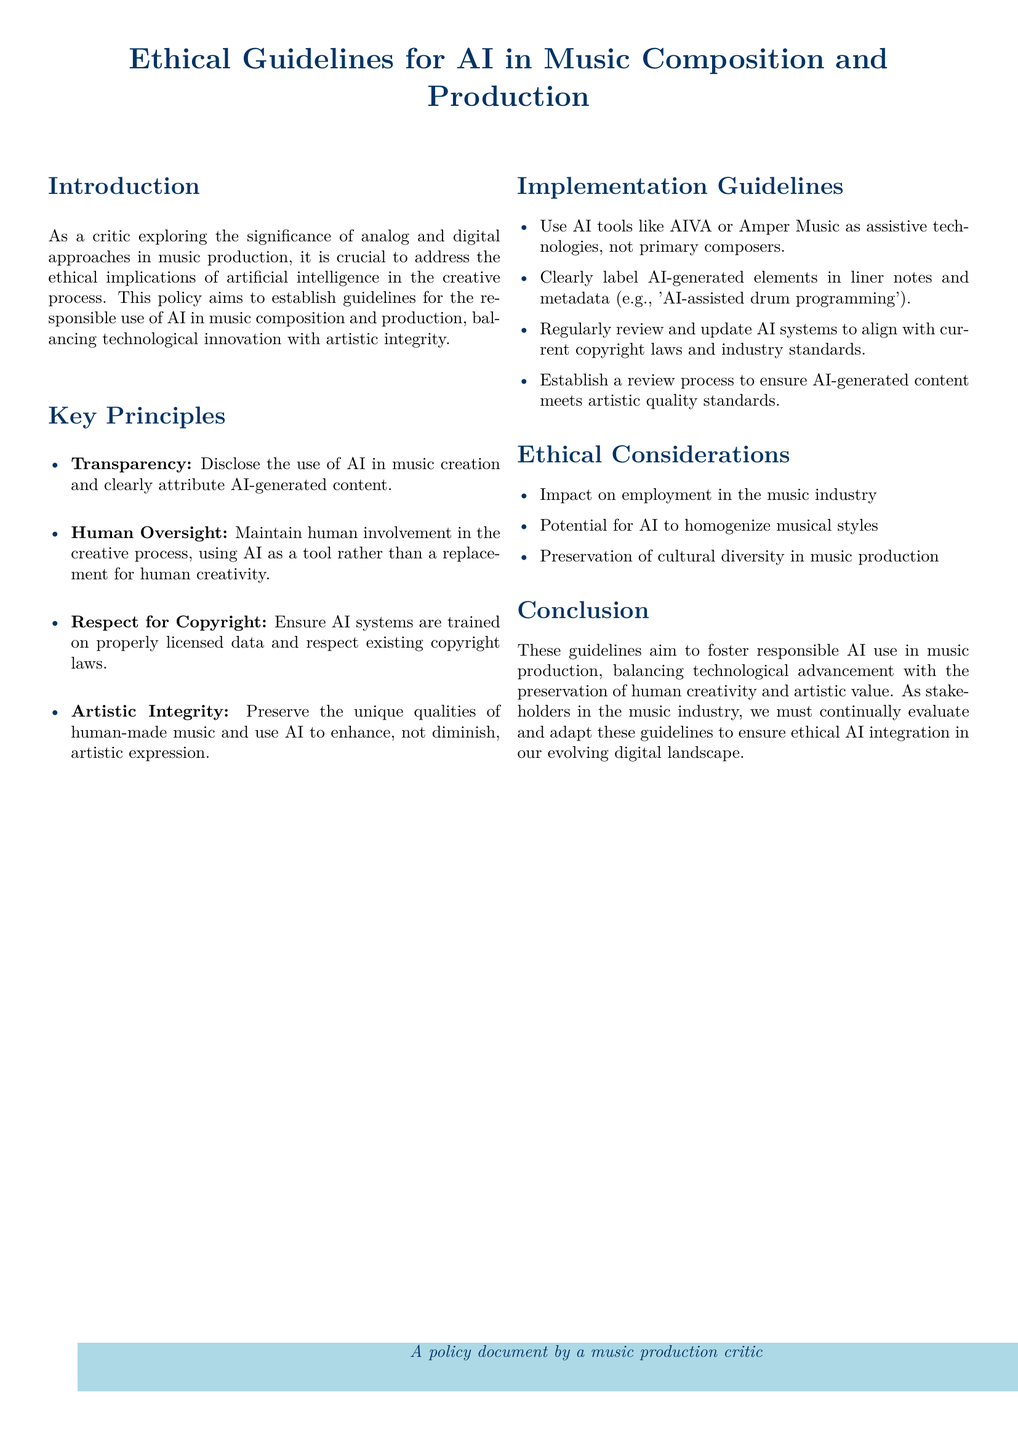What is the main purpose of the policy? The purpose of the policy is to establish guidelines for the responsible use of AI in music composition and production.
Answer: responsible use of AI in music composition and production How many key principles are outlined in the document? The document lists four key principles.
Answer: four What is the first key principle mentioned? The first key principle emphasizes the necessity of disclosing AI use in music creation.
Answer: Transparency What is one ethical consideration mentioned in the guidelines? One ethical consideration is the impact on employment in the music industry.
Answer: impact on employment in the music industry What should AI be used as in the music production process? The guidelines state that AI should be used as a tool rather than a replacement for human creativity.
Answer: tool How should AI-generated elements be labeled in music projects? AI-generated elements should be clearly labeled in liner notes and metadata.
Answer: labeled in liner notes and metadata What type of music tools should be used according to the implementation guidelines? The guidelines suggest using AI tools like AIVA or Amper Music as assistive technologies.
Answer: assistive technologies Which section addresses potential homogenization of musical styles? The ethical considerations section addresses the potential for AI to homogenize musical styles.
Answer: ethical considerations What is the concluding aim of these guidelines? The concluding aim is to foster responsible AI use while preserving human creativity and artistic value.
Answer: foster responsible AI use while preserving human creativity and artistic value 